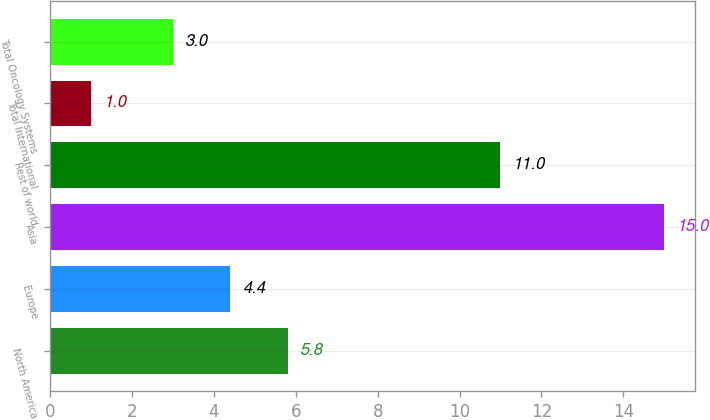<chart> <loc_0><loc_0><loc_500><loc_500><bar_chart><fcel>North America<fcel>Europe<fcel>Asia<fcel>Rest of world<fcel>Total International<fcel>Total Oncology Systems<nl><fcel>5.8<fcel>4.4<fcel>15<fcel>11<fcel>1<fcel>3<nl></chart> 